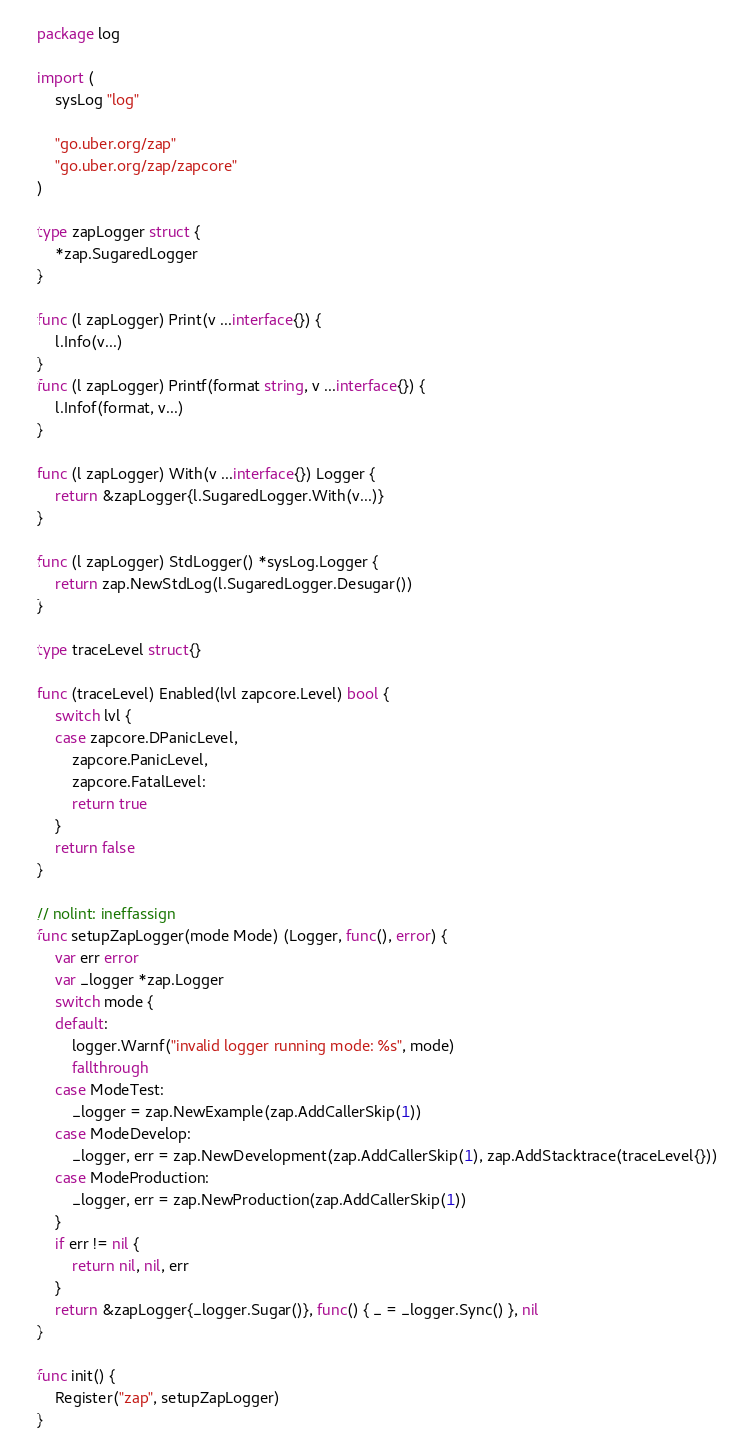<code> <loc_0><loc_0><loc_500><loc_500><_Go_>package log

import (
	sysLog "log"

	"go.uber.org/zap"
	"go.uber.org/zap/zapcore"
)

type zapLogger struct {
	*zap.SugaredLogger
}

func (l zapLogger) Print(v ...interface{}) {
	l.Info(v...)
}
func (l zapLogger) Printf(format string, v ...interface{}) {
	l.Infof(format, v...)
}

func (l zapLogger) With(v ...interface{}) Logger {
	return &zapLogger{l.SugaredLogger.With(v...)}
}

func (l zapLogger) StdLogger() *sysLog.Logger {
	return zap.NewStdLog(l.SugaredLogger.Desugar())
}

type traceLevel struct{}

func (traceLevel) Enabled(lvl zapcore.Level) bool {
	switch lvl {
	case zapcore.DPanicLevel,
		zapcore.PanicLevel,
		zapcore.FatalLevel:
		return true
	}
	return false
}

// nolint: ineffassign
func setupZapLogger(mode Mode) (Logger, func(), error) {
	var err error
	var _logger *zap.Logger
	switch mode {
	default:
		logger.Warnf("invalid logger running mode: %s", mode)
		fallthrough
	case ModeTest:
		_logger = zap.NewExample(zap.AddCallerSkip(1))
	case ModeDevelop:
		_logger, err = zap.NewDevelopment(zap.AddCallerSkip(1), zap.AddStacktrace(traceLevel{}))
	case ModeProduction:
		_logger, err = zap.NewProduction(zap.AddCallerSkip(1))
	}
	if err != nil {
		return nil, nil, err
	}
	return &zapLogger{_logger.Sugar()}, func() { _ = _logger.Sync() }, nil
}

func init() {
	Register("zap", setupZapLogger)
}
</code> 